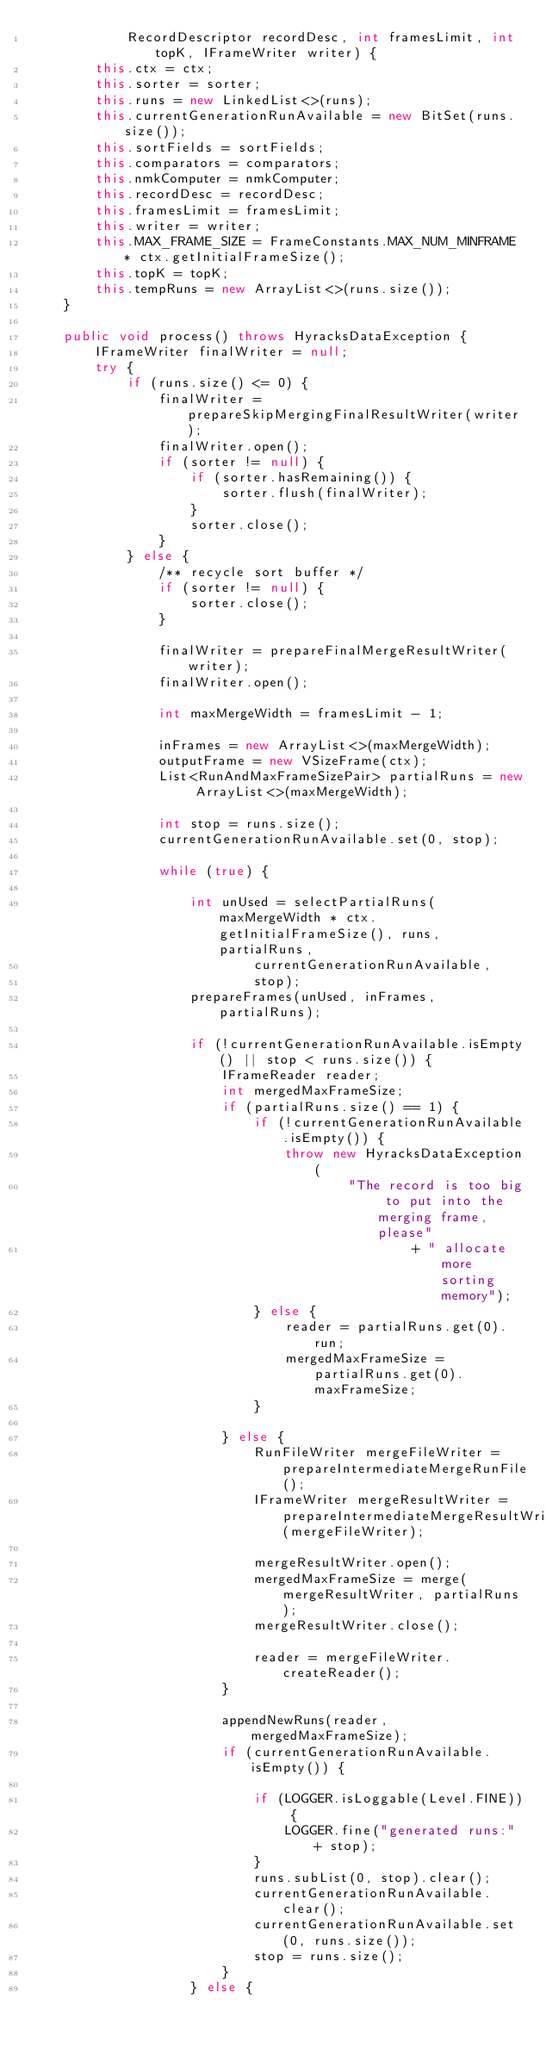Convert code to text. <code><loc_0><loc_0><loc_500><loc_500><_Java_>            RecordDescriptor recordDesc, int framesLimit, int topK, IFrameWriter writer) {
        this.ctx = ctx;
        this.sorter = sorter;
        this.runs = new LinkedList<>(runs);
        this.currentGenerationRunAvailable = new BitSet(runs.size());
        this.sortFields = sortFields;
        this.comparators = comparators;
        this.nmkComputer = nmkComputer;
        this.recordDesc = recordDesc;
        this.framesLimit = framesLimit;
        this.writer = writer;
        this.MAX_FRAME_SIZE = FrameConstants.MAX_NUM_MINFRAME * ctx.getInitialFrameSize();
        this.topK = topK;
        this.tempRuns = new ArrayList<>(runs.size());
    }

    public void process() throws HyracksDataException {
        IFrameWriter finalWriter = null;
        try {
            if (runs.size() <= 0) {
                finalWriter = prepareSkipMergingFinalResultWriter(writer);
                finalWriter.open();
                if (sorter != null) {
                    if (sorter.hasRemaining()) {
                        sorter.flush(finalWriter);
                    }
                    sorter.close();
                }
            } else {
                /** recycle sort buffer */
                if (sorter != null) {
                    sorter.close();
                }

                finalWriter = prepareFinalMergeResultWriter(writer);
                finalWriter.open();

                int maxMergeWidth = framesLimit - 1;

                inFrames = new ArrayList<>(maxMergeWidth);
                outputFrame = new VSizeFrame(ctx);
                List<RunAndMaxFrameSizePair> partialRuns = new ArrayList<>(maxMergeWidth);

                int stop = runs.size();
                currentGenerationRunAvailable.set(0, stop);

                while (true) {

                    int unUsed = selectPartialRuns(maxMergeWidth * ctx.getInitialFrameSize(), runs, partialRuns,
                            currentGenerationRunAvailable,
                            stop);
                    prepareFrames(unUsed, inFrames, partialRuns);

                    if (!currentGenerationRunAvailable.isEmpty() || stop < runs.size()) {
                        IFrameReader reader;
                        int mergedMaxFrameSize;
                        if (partialRuns.size() == 1) {
                            if (!currentGenerationRunAvailable.isEmpty()) {
                                throw new HyracksDataException(
                                        "The record is too big to put into the merging frame, please"
                                                + " allocate more sorting memory");
                            } else {
                                reader = partialRuns.get(0).run;
                                mergedMaxFrameSize = partialRuns.get(0).maxFrameSize;
                            }

                        } else {
                            RunFileWriter mergeFileWriter = prepareIntermediateMergeRunFile();
                            IFrameWriter mergeResultWriter = prepareIntermediateMergeResultWriter(mergeFileWriter);

                            mergeResultWriter.open();
                            mergedMaxFrameSize = merge(mergeResultWriter, partialRuns);
                            mergeResultWriter.close();

                            reader = mergeFileWriter.createReader();
                        }

                        appendNewRuns(reader, mergedMaxFrameSize);
                        if (currentGenerationRunAvailable.isEmpty()) {

                            if (LOGGER.isLoggable(Level.FINE)) {
                                LOGGER.fine("generated runs:" + stop);
                            }
                            runs.subList(0, stop).clear();
                            currentGenerationRunAvailable.clear();
                            currentGenerationRunAvailable.set(0, runs.size());
                            stop = runs.size();
                        }
                    } else {</code> 